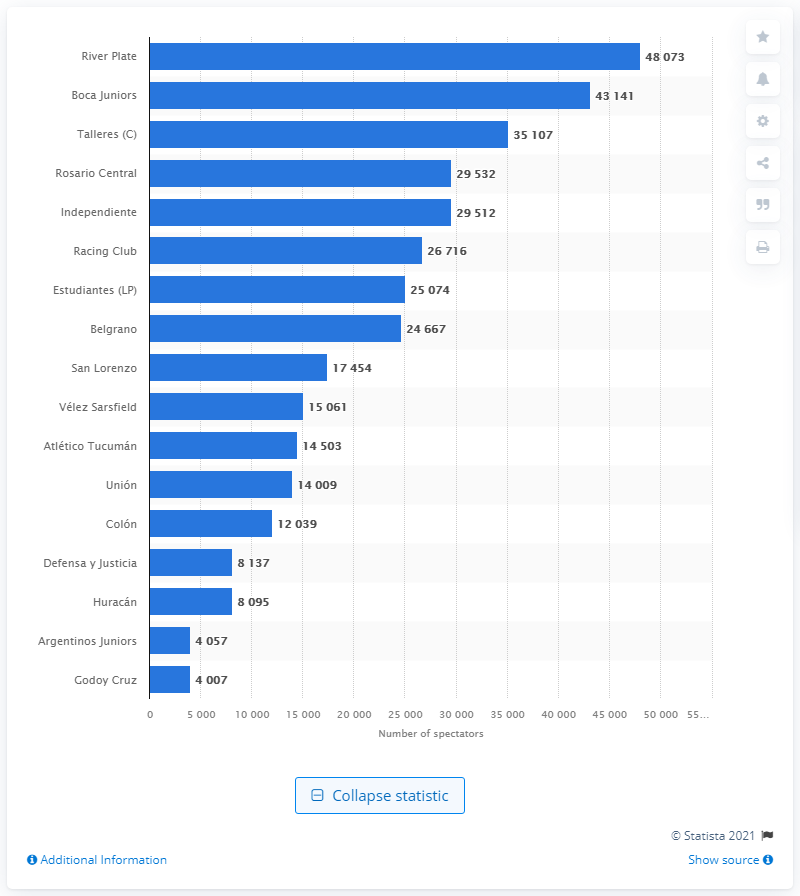Identify some key points in this picture. Last season, Boca Juniors had an average of 43,141 spectators per game, demonstrating the strong support for the team among its passionate fan base. 